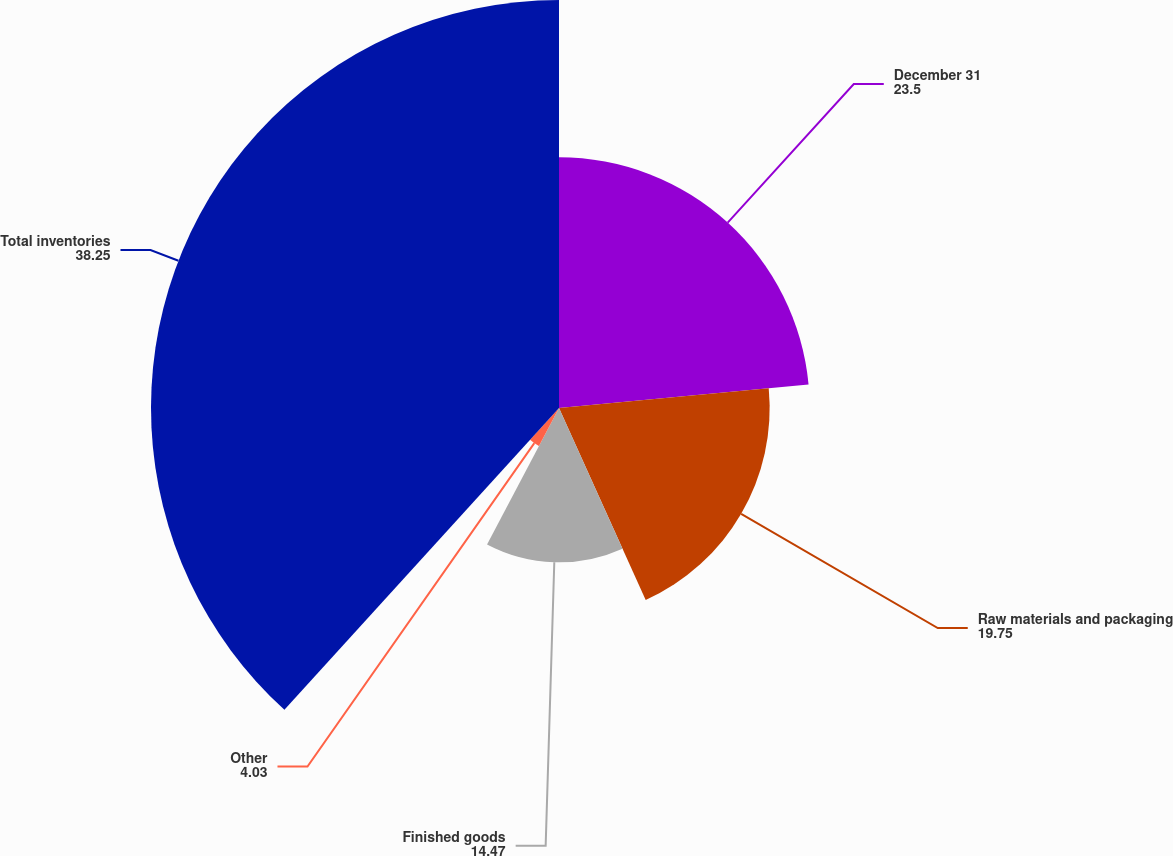Convert chart to OTSL. <chart><loc_0><loc_0><loc_500><loc_500><pie_chart><fcel>December 31<fcel>Raw materials and packaging<fcel>Finished goods<fcel>Other<fcel>Total inventories<nl><fcel>23.5%<fcel>19.75%<fcel>14.47%<fcel>4.03%<fcel>38.25%<nl></chart> 